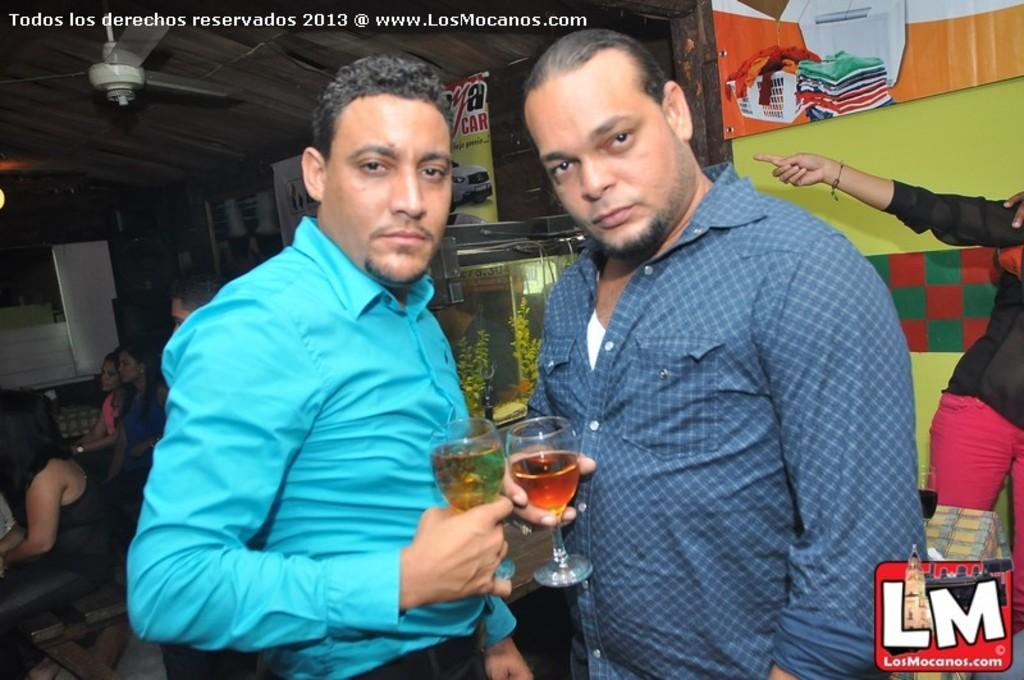How many men are in the image? There are two men in the image. What are the men doing in the image? The men are standing and holding a glass in each of their hands. What can be seen in the background of the image? There is a fan, people sitting on chairs, hoardings and banners, and plants in the background of the image. What type of paste is being used by the men in the image? There is no paste visible in the image; the men are holding glasses. What kind of toys are present in the image? There are no toys present in the image. 